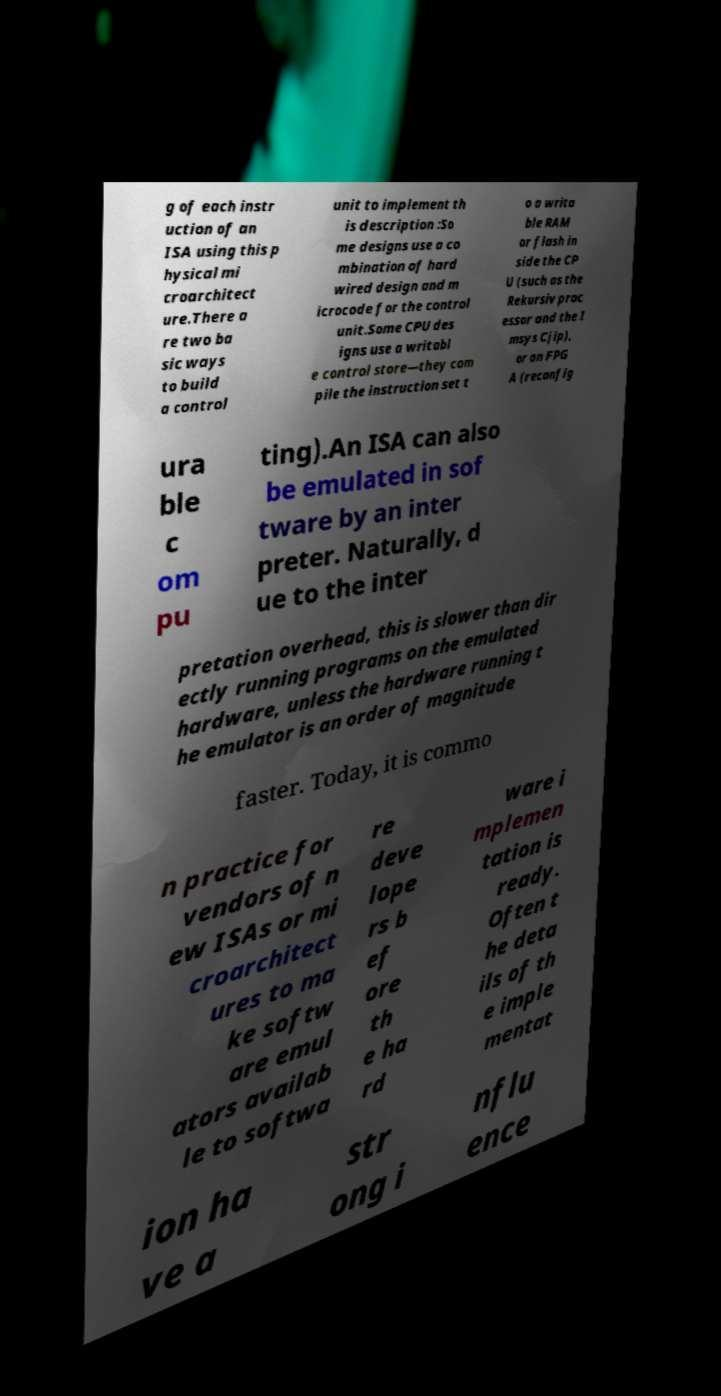I need the written content from this picture converted into text. Can you do that? g of each instr uction of an ISA using this p hysical mi croarchitect ure.There a re two ba sic ways to build a control unit to implement th is description :So me designs use a co mbination of hard wired design and m icrocode for the control unit.Some CPU des igns use a writabl e control store—they com pile the instruction set t o a writa ble RAM or flash in side the CP U (such as the Rekursiv proc essor and the I msys Cjip), or an FPG A (reconfig ura ble c om pu ting).An ISA can also be emulated in sof tware by an inter preter. Naturally, d ue to the inter pretation overhead, this is slower than dir ectly running programs on the emulated hardware, unless the hardware running t he emulator is an order of magnitude faster. Today, it is commo n practice for vendors of n ew ISAs or mi croarchitect ures to ma ke softw are emul ators availab le to softwa re deve lope rs b ef ore th e ha rd ware i mplemen tation is ready. Often t he deta ils of th e imple mentat ion ha ve a str ong i nflu ence 